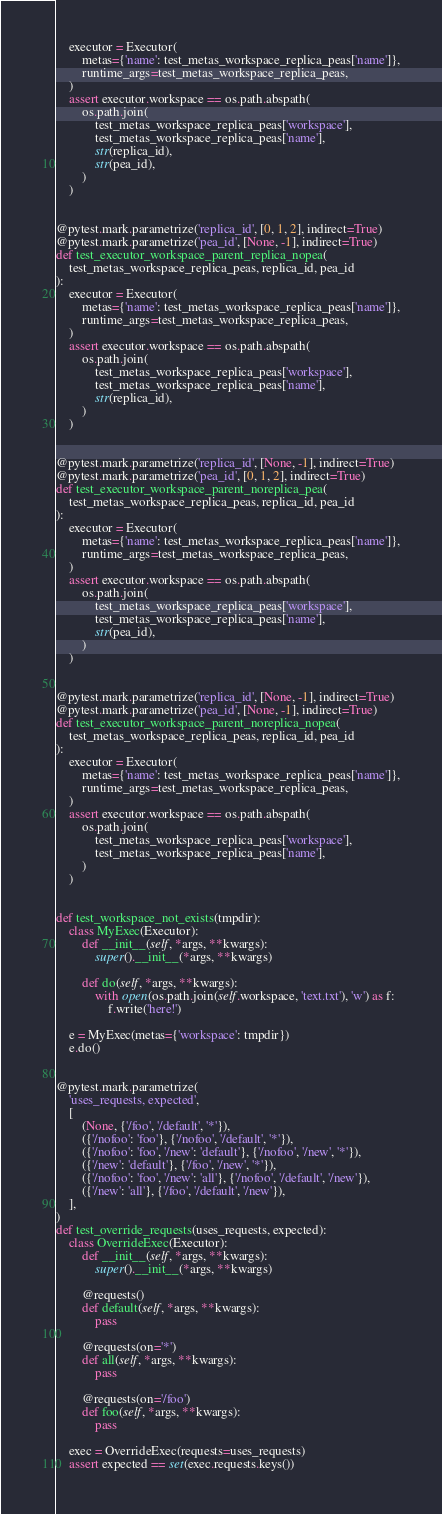<code> <loc_0><loc_0><loc_500><loc_500><_Python_>    executor = Executor(
        metas={'name': test_metas_workspace_replica_peas['name']},
        runtime_args=test_metas_workspace_replica_peas,
    )
    assert executor.workspace == os.path.abspath(
        os.path.join(
            test_metas_workspace_replica_peas['workspace'],
            test_metas_workspace_replica_peas['name'],
            str(replica_id),
            str(pea_id),
        )
    )


@pytest.mark.parametrize('replica_id', [0, 1, 2], indirect=True)
@pytest.mark.parametrize('pea_id', [None, -1], indirect=True)
def test_executor_workspace_parent_replica_nopea(
    test_metas_workspace_replica_peas, replica_id, pea_id
):
    executor = Executor(
        metas={'name': test_metas_workspace_replica_peas['name']},
        runtime_args=test_metas_workspace_replica_peas,
    )
    assert executor.workspace == os.path.abspath(
        os.path.join(
            test_metas_workspace_replica_peas['workspace'],
            test_metas_workspace_replica_peas['name'],
            str(replica_id),
        )
    )


@pytest.mark.parametrize('replica_id', [None, -1], indirect=True)
@pytest.mark.parametrize('pea_id', [0, 1, 2], indirect=True)
def test_executor_workspace_parent_noreplica_pea(
    test_metas_workspace_replica_peas, replica_id, pea_id
):
    executor = Executor(
        metas={'name': test_metas_workspace_replica_peas['name']},
        runtime_args=test_metas_workspace_replica_peas,
    )
    assert executor.workspace == os.path.abspath(
        os.path.join(
            test_metas_workspace_replica_peas['workspace'],
            test_metas_workspace_replica_peas['name'],
            str(pea_id),
        )
    )


@pytest.mark.parametrize('replica_id', [None, -1], indirect=True)
@pytest.mark.parametrize('pea_id', [None, -1], indirect=True)
def test_executor_workspace_parent_noreplica_nopea(
    test_metas_workspace_replica_peas, replica_id, pea_id
):
    executor = Executor(
        metas={'name': test_metas_workspace_replica_peas['name']},
        runtime_args=test_metas_workspace_replica_peas,
    )
    assert executor.workspace == os.path.abspath(
        os.path.join(
            test_metas_workspace_replica_peas['workspace'],
            test_metas_workspace_replica_peas['name'],
        )
    )


def test_workspace_not_exists(tmpdir):
    class MyExec(Executor):
        def __init__(self, *args, **kwargs):
            super().__init__(*args, **kwargs)

        def do(self, *args, **kwargs):
            with open(os.path.join(self.workspace, 'text.txt'), 'w') as f:
                f.write('here!')

    e = MyExec(metas={'workspace': tmpdir})
    e.do()


@pytest.mark.parametrize(
    'uses_requests, expected',
    [
        (None, {'/foo', '/default', '*'}),
        ({'/nofoo': 'foo'}, {'/nofoo', '/default', '*'}),
        ({'/nofoo': 'foo', '/new': 'default'}, {'/nofoo', '/new', '*'}),
        ({'/new': 'default'}, {'/foo', '/new', '*'}),
        ({'/nofoo': 'foo', '/new': 'all'}, {'/nofoo', '/default', '/new'}),
        ({'/new': 'all'}, {'/foo', '/default', '/new'}),
    ],
)
def test_override_requests(uses_requests, expected):
    class OverrideExec(Executor):
        def __init__(self, *args, **kwargs):
            super().__init__(*args, **kwargs)

        @requests()
        def default(self, *args, **kwargs):
            pass

        @requests(on='*')
        def all(self, *args, **kwargs):
            pass

        @requests(on='/foo')
        def foo(self, *args, **kwargs):
            pass

    exec = OverrideExec(requests=uses_requests)
    assert expected == set(exec.requests.keys())
</code> 